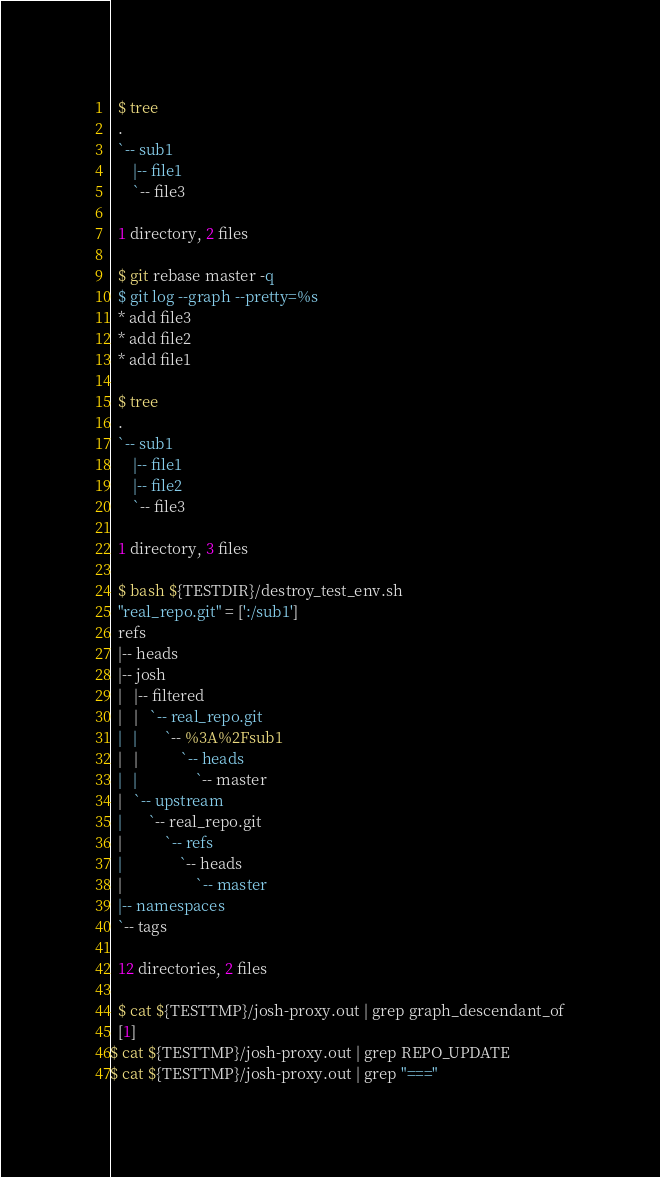Convert code to text. <code><loc_0><loc_0><loc_500><loc_500><_Perl_>  $ tree
  .
  `-- sub1
      |-- file1
      `-- file3
  
  1 directory, 2 files

  $ git rebase master -q
  $ git log --graph --pretty=%s
  * add file3
  * add file2
  * add file1

  $ tree
  .
  `-- sub1
      |-- file1
      |-- file2
      `-- file3
  
  1 directory, 3 files

  $ bash ${TESTDIR}/destroy_test_env.sh
  "real_repo.git" = [':/sub1']
  refs
  |-- heads
  |-- josh
  |   |-- filtered
  |   |   `-- real_repo.git
  |   |       `-- %3A%2Fsub1
  |   |           `-- heads
  |   |               `-- master
  |   `-- upstream
  |       `-- real_repo.git
  |           `-- refs
  |               `-- heads
  |                   `-- master
  |-- namespaces
  `-- tags
  
  12 directories, 2 files

  $ cat ${TESTTMP}/josh-proxy.out | grep graph_descendant_of
  [1]
$ cat ${TESTTMP}/josh-proxy.out | grep REPO_UPDATE
$ cat ${TESTTMP}/josh-proxy.out | grep "==="
</code> 